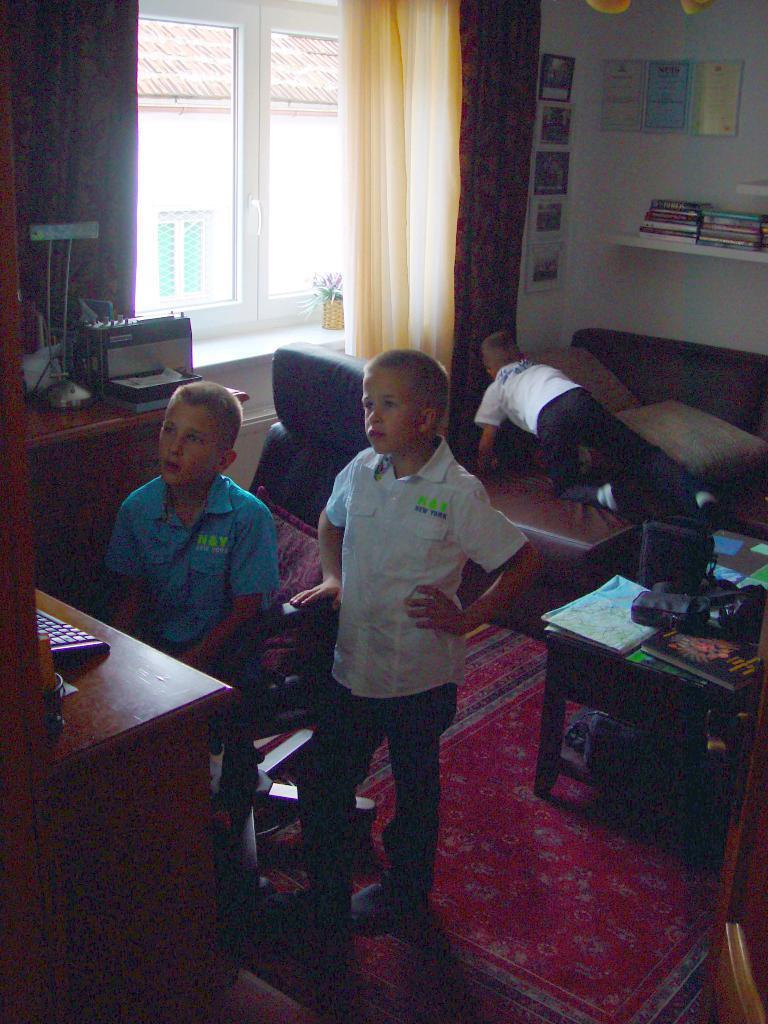Please provide a concise description of this image. In this image I can two boys in the front and one boy is in the background. I can see a window with cream color of curtain. I can also see a white color of wall and red mattress on the floor. I can see a keyboard, a chair and few items on the table. 